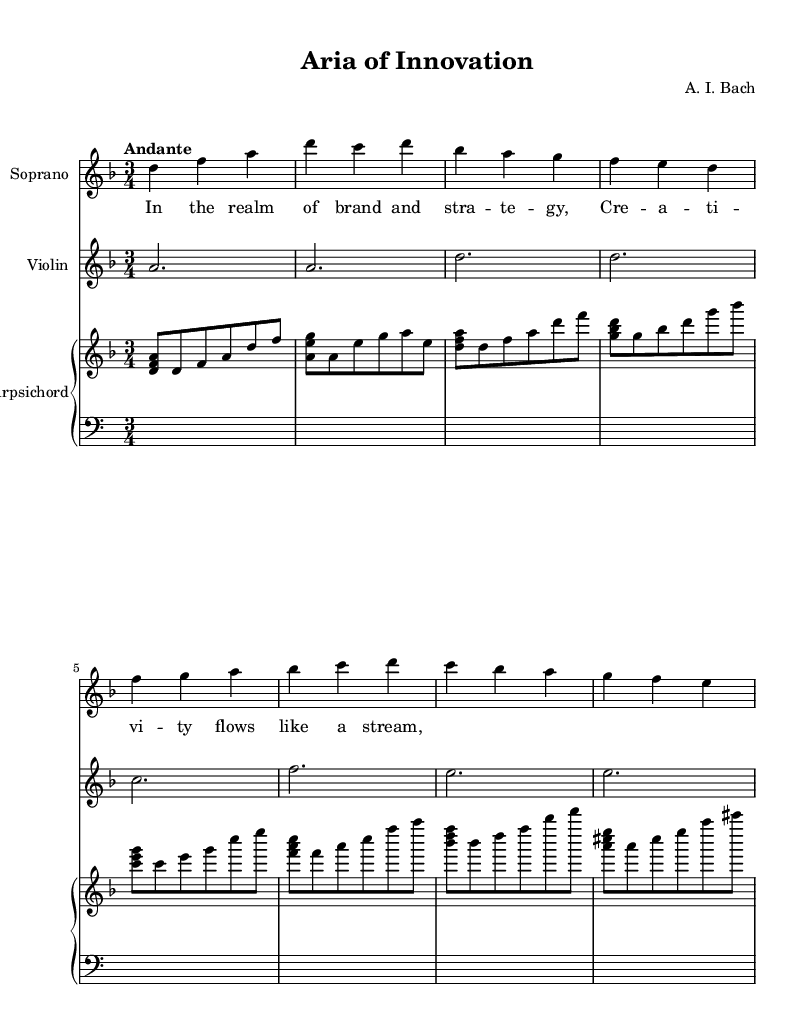What is the key signature of this music? The key signature is indicated at the beginning of the staff, showing two flats (B and E). This means the piece is in the key of D minor.
Answer: D minor What is the time signature of the piece? The time signature is presented right after the key signature and is shown as a '3 over 4', indicating that there are 3 beats in each measure and the quarter note gets one beat.
Answer: 3/4 What is the tempo marking for this composition? The tempo marking is located at the beginning of the score, indicating "Andante," which signifies a moderately slow tempo.
Answer: Andante How many measures are in the soprano part? By counting the measure lines in the soprano staff, there are a total of 8 distinct measures present.
Answer: 8 What is the instrument playing the lowest line? The lowest line is played by the Harpsichord, which is typical in Baroque music, providing harmonic and rhythmic support below the Soprano melody.
Answer: Harpsichord What is a characteristic melodic feature of Baroque vocal works seen in this piece? The Soprano part displays ornamentation and a flowing lyrical line, which are typical in Baroque music to enhance expressiveness. This embellishes the melody and adds emotional depth.
Answer: Ornamentation 